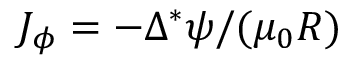<formula> <loc_0><loc_0><loc_500><loc_500>J _ { \phi } = - \Delta ^ { * } \psi / ( \mu _ { 0 } R )</formula> 